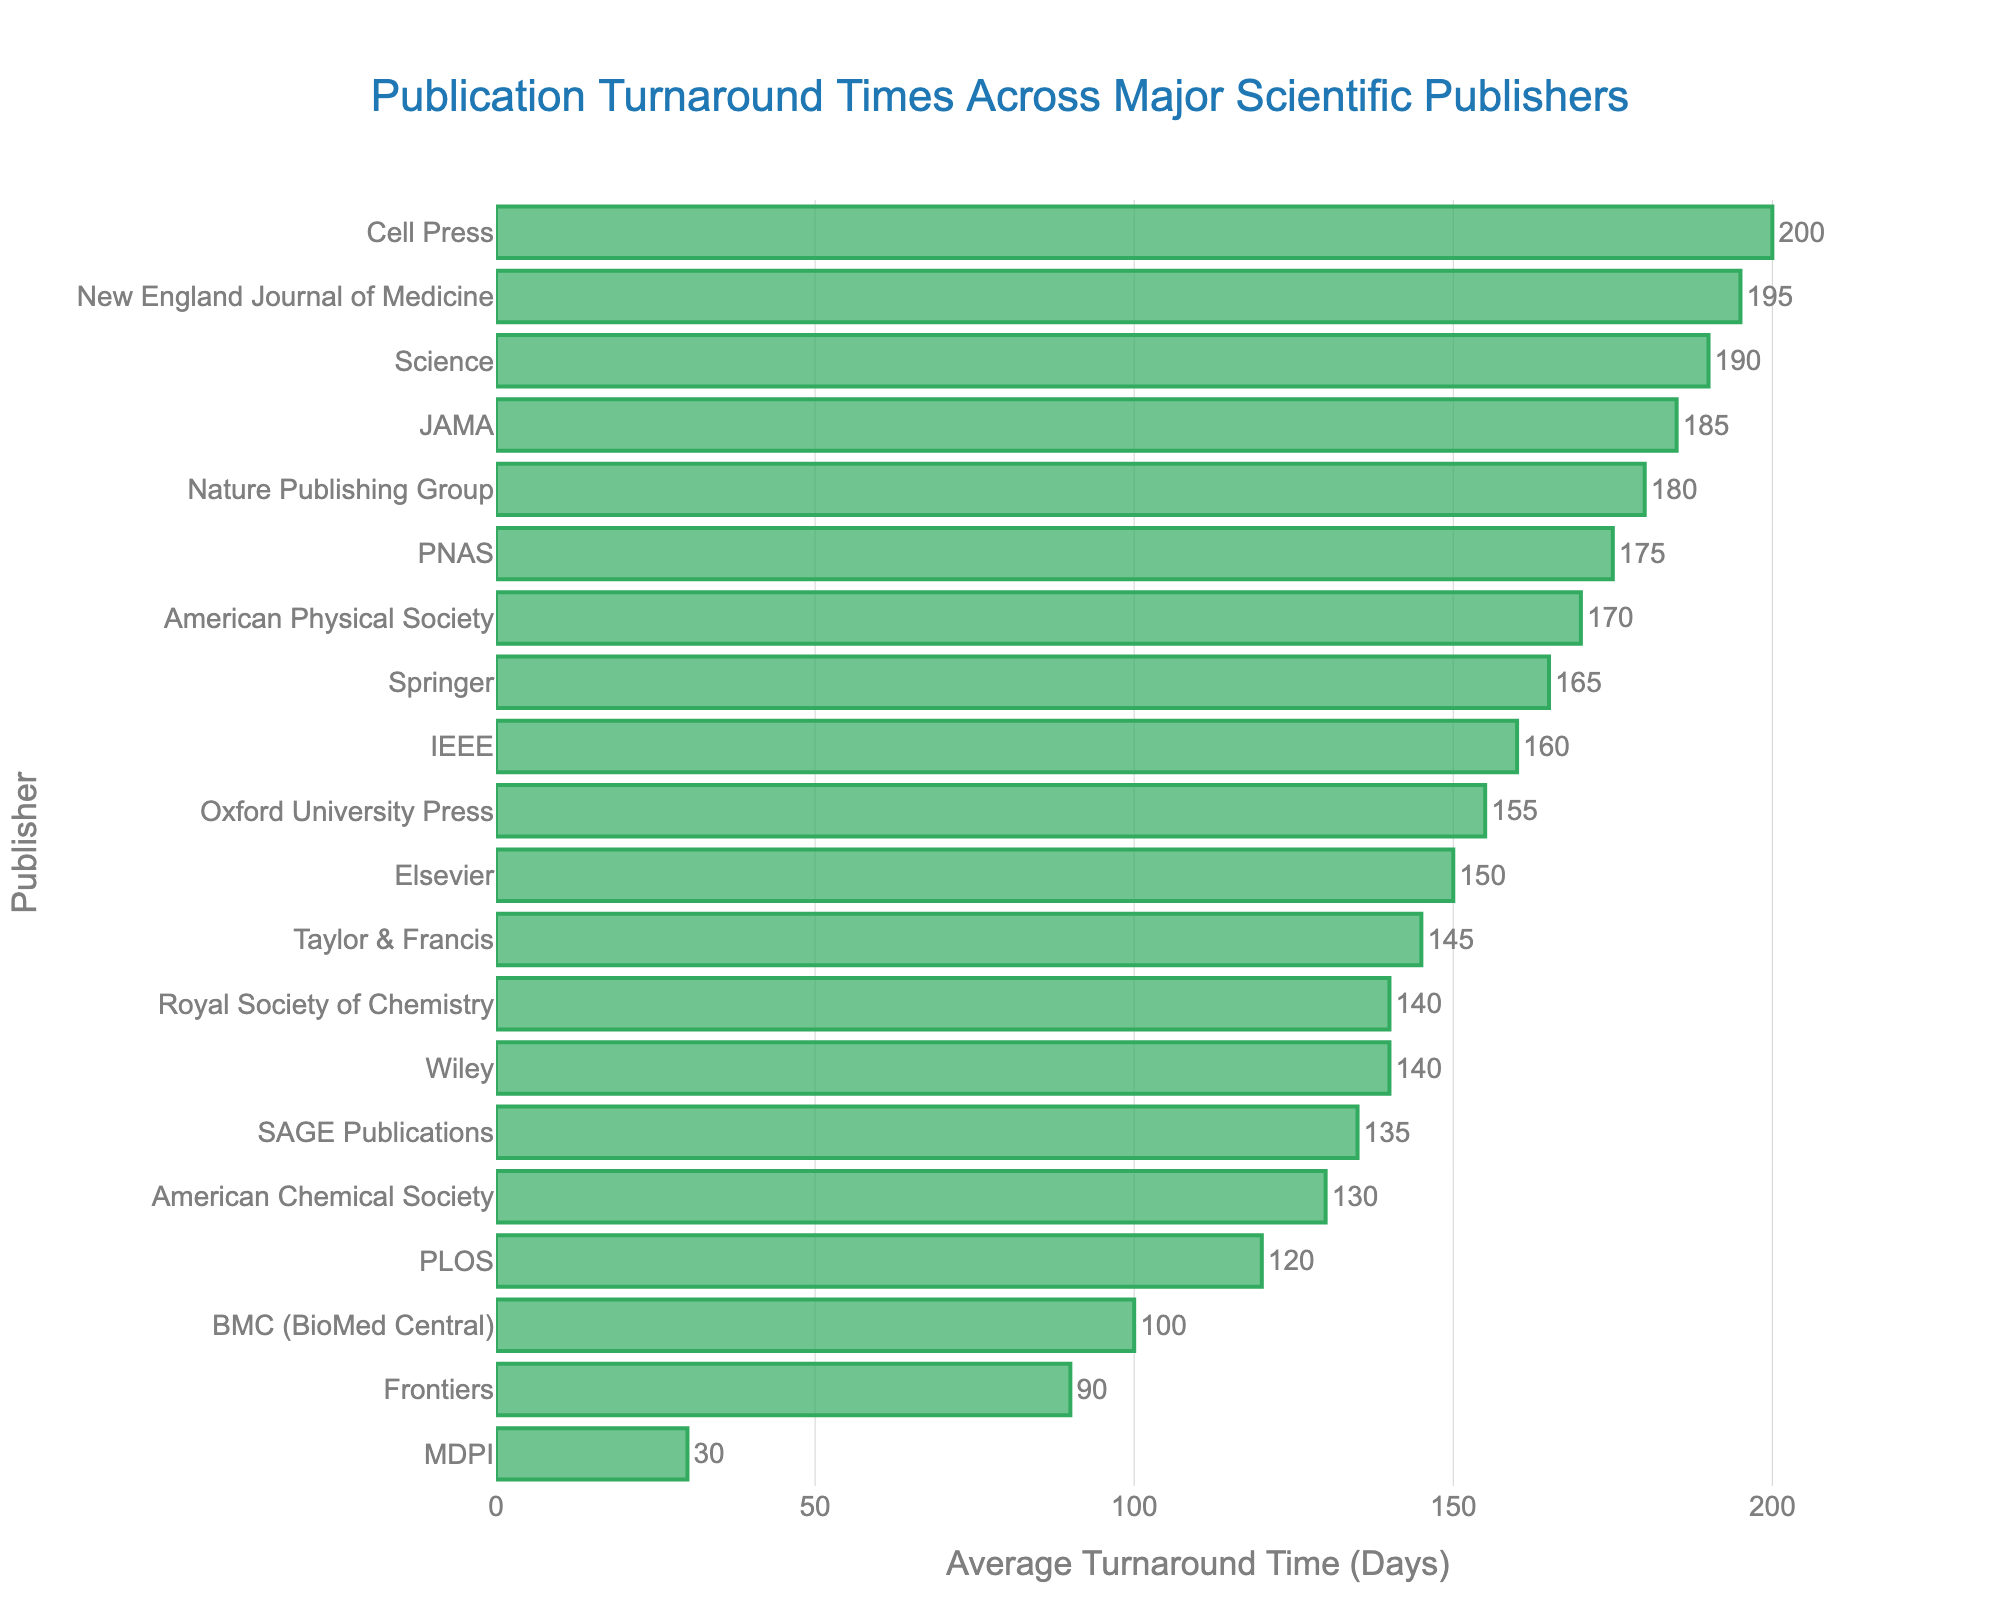Which publisher has the shortest average turnaround time? By examining the length of the bars, we can see that MDPI has the shortest bar. The corresponding turnaround time for MDPI is clearly listed as 30 days.
Answer: MDPI Which publisher has the longest turnaround time? The longest bar represents Cell Press, with an average turnaround time listed as 200 days. This is visually the longest bar in the chart.
Answer: Cell Press What is the difference between the turnaround times of Science and BMC (BioMed Central)? Science has an average turnaround time of 190 days, and BMC has 100 days. Subtracting these gives: 190 - 100 = 90 days.
Answer: 90 days What is the average of the three shortest turnaround times? The three shortest turnaround times are MDPI (30 days), Frontiers (90 days), and BMC (BioMed Central) (100 days). Their average is (30 + 90 + 100) / 3 = 220 / 3 ≈ 73.33 days.
Answer: 73.33 days How many publishers have a turnaround time greater than 150 days? By counting the bars longer than 150 days, we find that seven publishers meet this criterion: Nature Publishing Group, Springer, IEEE, American Physical Society, JAMA, Science, and New England Journal of Medicine.
Answer: 7 Which publisher's turnaround time is closest to the median? To find the median, arrange the turnaround times in ascending order and locate the middle value. After arranging, the median is 155 days. Oxford University Press, with a turnaround time of 155 days, is the closest to this median value.
Answer: Oxford University Press Which two publishers have the same average turnaround time, and what is it? By examining the bars, we see that Wiley and the Royal Society of Chemistry both have bars of the same length. The corresponding value is 140 days.
Answer: Wiley and Royal Society of Chemistry, 140 days By how much does the turnaround time of Nature Publishing Group exceed that of PLOS? Nature Publishing Group has an average turnaround time of 180 days, and PLOS has 120 days. The difference is 180 - 120 = 60 days.
Answer: 60 days Which publishers have an average turnaround time between 130 and 150 days? The publishers fitting this range are SAGE Publications (135 days), American Chemical Society (130 days), Wiley (140 days), and Taylor & Francis (145 days).
Answer: SAGE Publications, American Chemical Society, Wiley, Taylor & Francis 